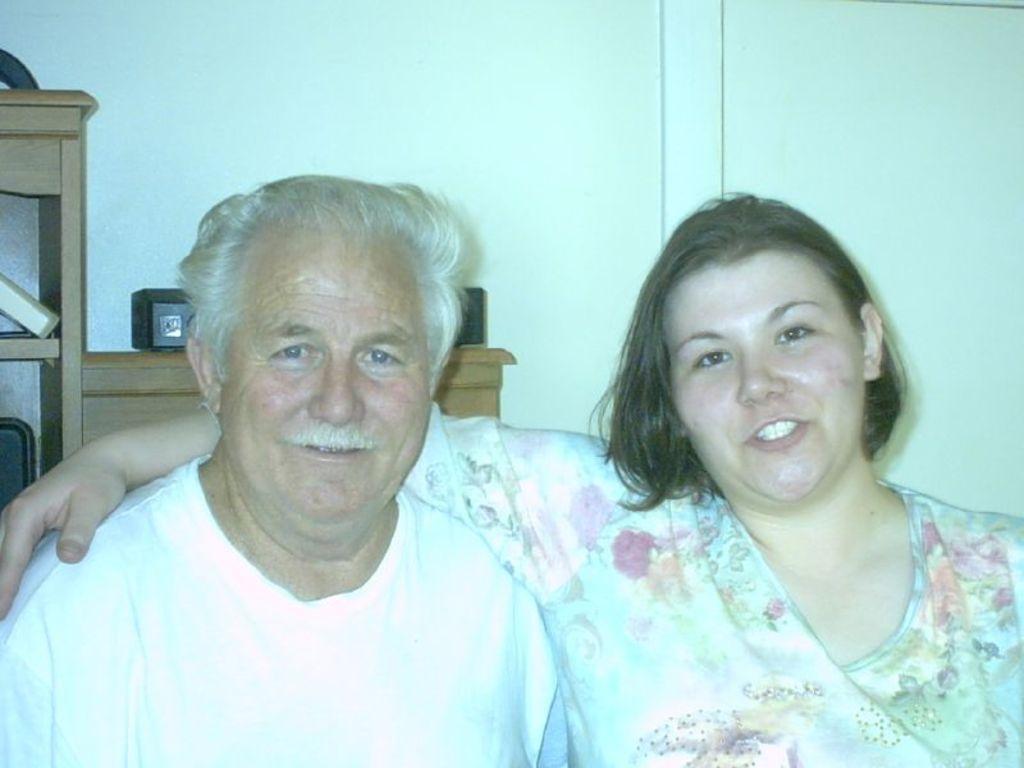Describe this image in one or two sentences. In this image we can see two persons with a smiling face and behind them, we can see the wall and wooden object. 